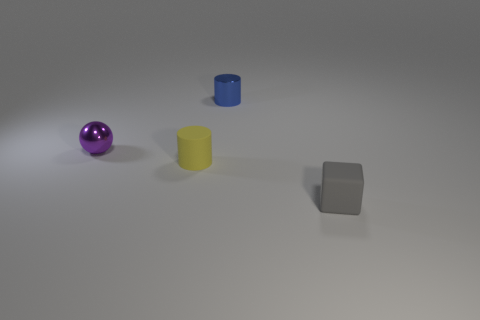Can you describe the different objects in terms of their colors and shapes? Certainly! There are three objects in the image, each with a distinct color and shape. Starting from the left, there is a purple sphere, glowing with a smooth luster. In the middle, there's a blue cylinder standing upright. And on the right sits a grey cube, solid with clearly defined edges. 